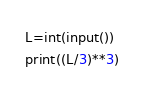<code> <loc_0><loc_0><loc_500><loc_500><_Python_>L=int(input())
print((L/3)**3)</code> 